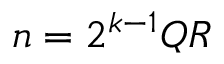Convert formula to latex. <formula><loc_0><loc_0><loc_500><loc_500>n = 2 ^ { k - 1 } Q R</formula> 